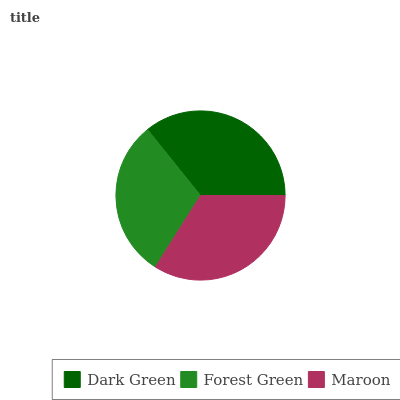Is Forest Green the minimum?
Answer yes or no. Yes. Is Dark Green the maximum?
Answer yes or no. Yes. Is Maroon the minimum?
Answer yes or no. No. Is Maroon the maximum?
Answer yes or no. No. Is Maroon greater than Forest Green?
Answer yes or no. Yes. Is Forest Green less than Maroon?
Answer yes or no. Yes. Is Forest Green greater than Maroon?
Answer yes or no. No. Is Maroon less than Forest Green?
Answer yes or no. No. Is Maroon the high median?
Answer yes or no. Yes. Is Maroon the low median?
Answer yes or no. Yes. Is Forest Green the high median?
Answer yes or no. No. Is Dark Green the low median?
Answer yes or no. No. 